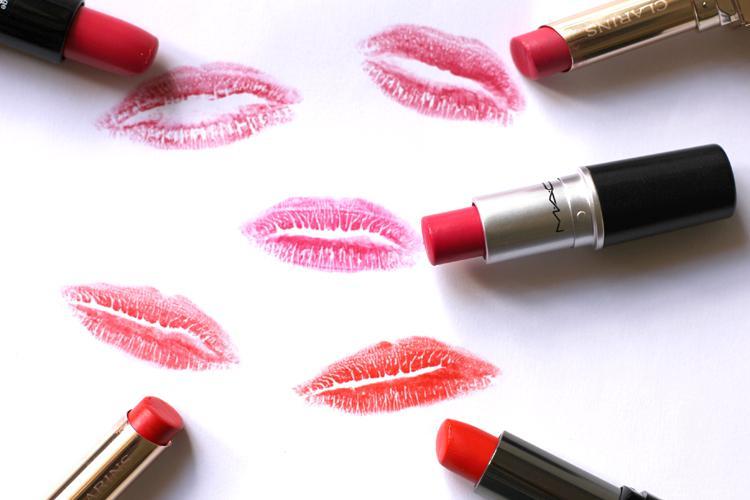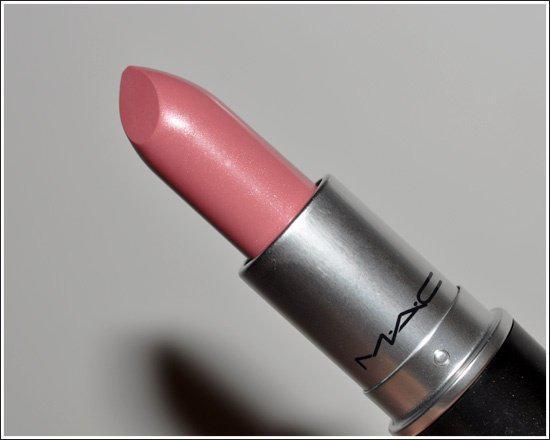The first image is the image on the left, the second image is the image on the right. Evaluate the accuracy of this statement regarding the images: "Lip shapes are depicted in one or more images.". Is it true? Answer yes or no. Yes. 